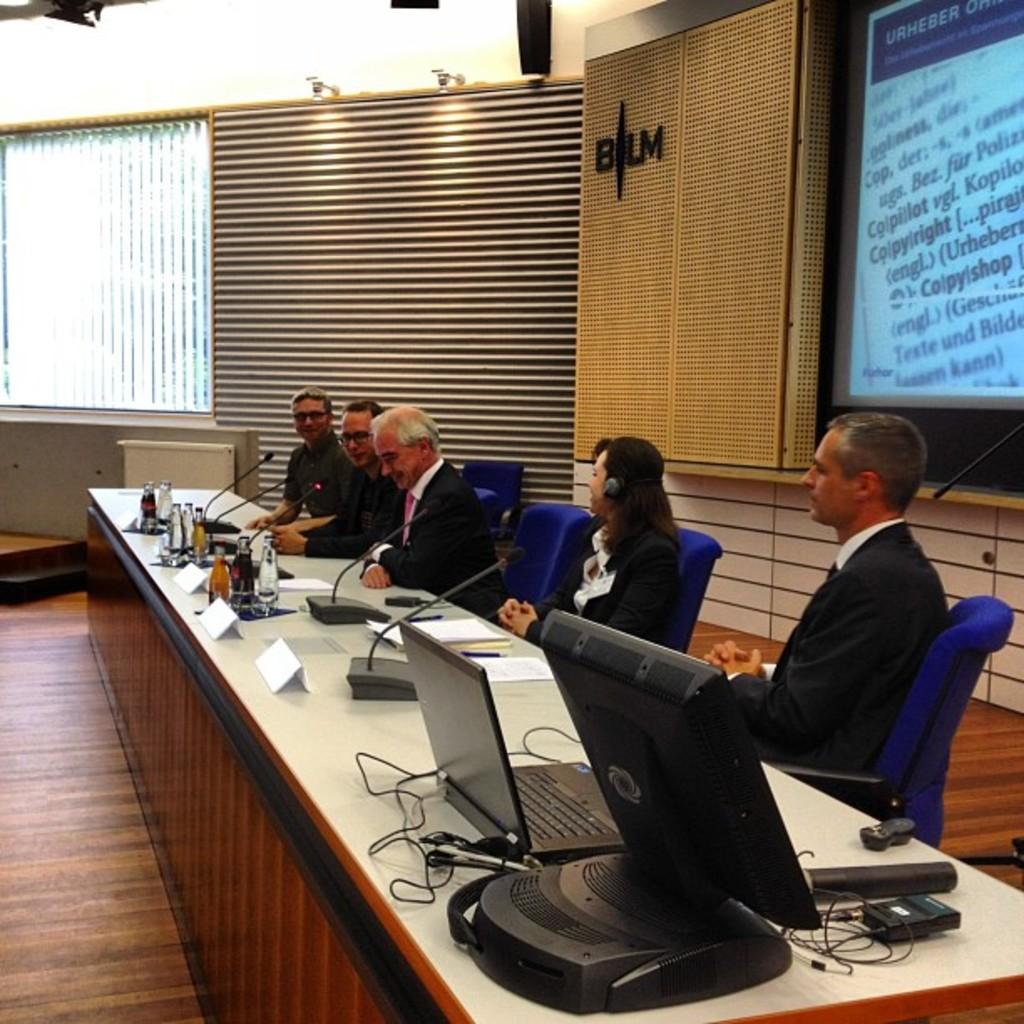What letters are on the tan banner?
Keep it short and to the point. Blm. This new model car?
Your answer should be compact. Unanswerable. 